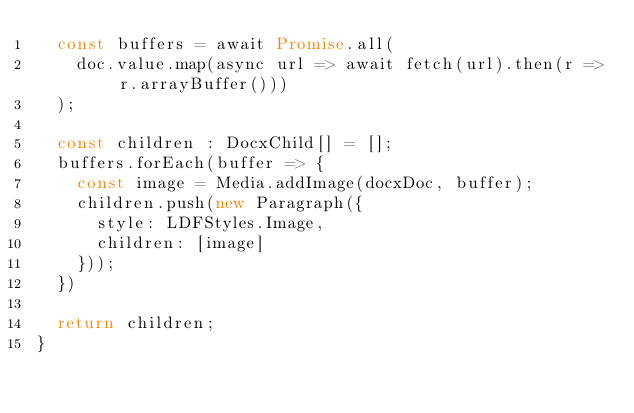Convert code to text. <code><loc_0><loc_0><loc_500><loc_500><_TypeScript_>  const buffers = await Promise.all(
    doc.value.map(async url => await fetch(url).then(r => r.arrayBuffer()))
  );

  const children : DocxChild[] = [];
  buffers.forEach(buffer => {
    const image = Media.addImage(docxDoc, buffer);
    children.push(new Paragraph({
      style: LDFStyles.Image,
      children: [image]
    }));
  })

  return children;
}
</code> 